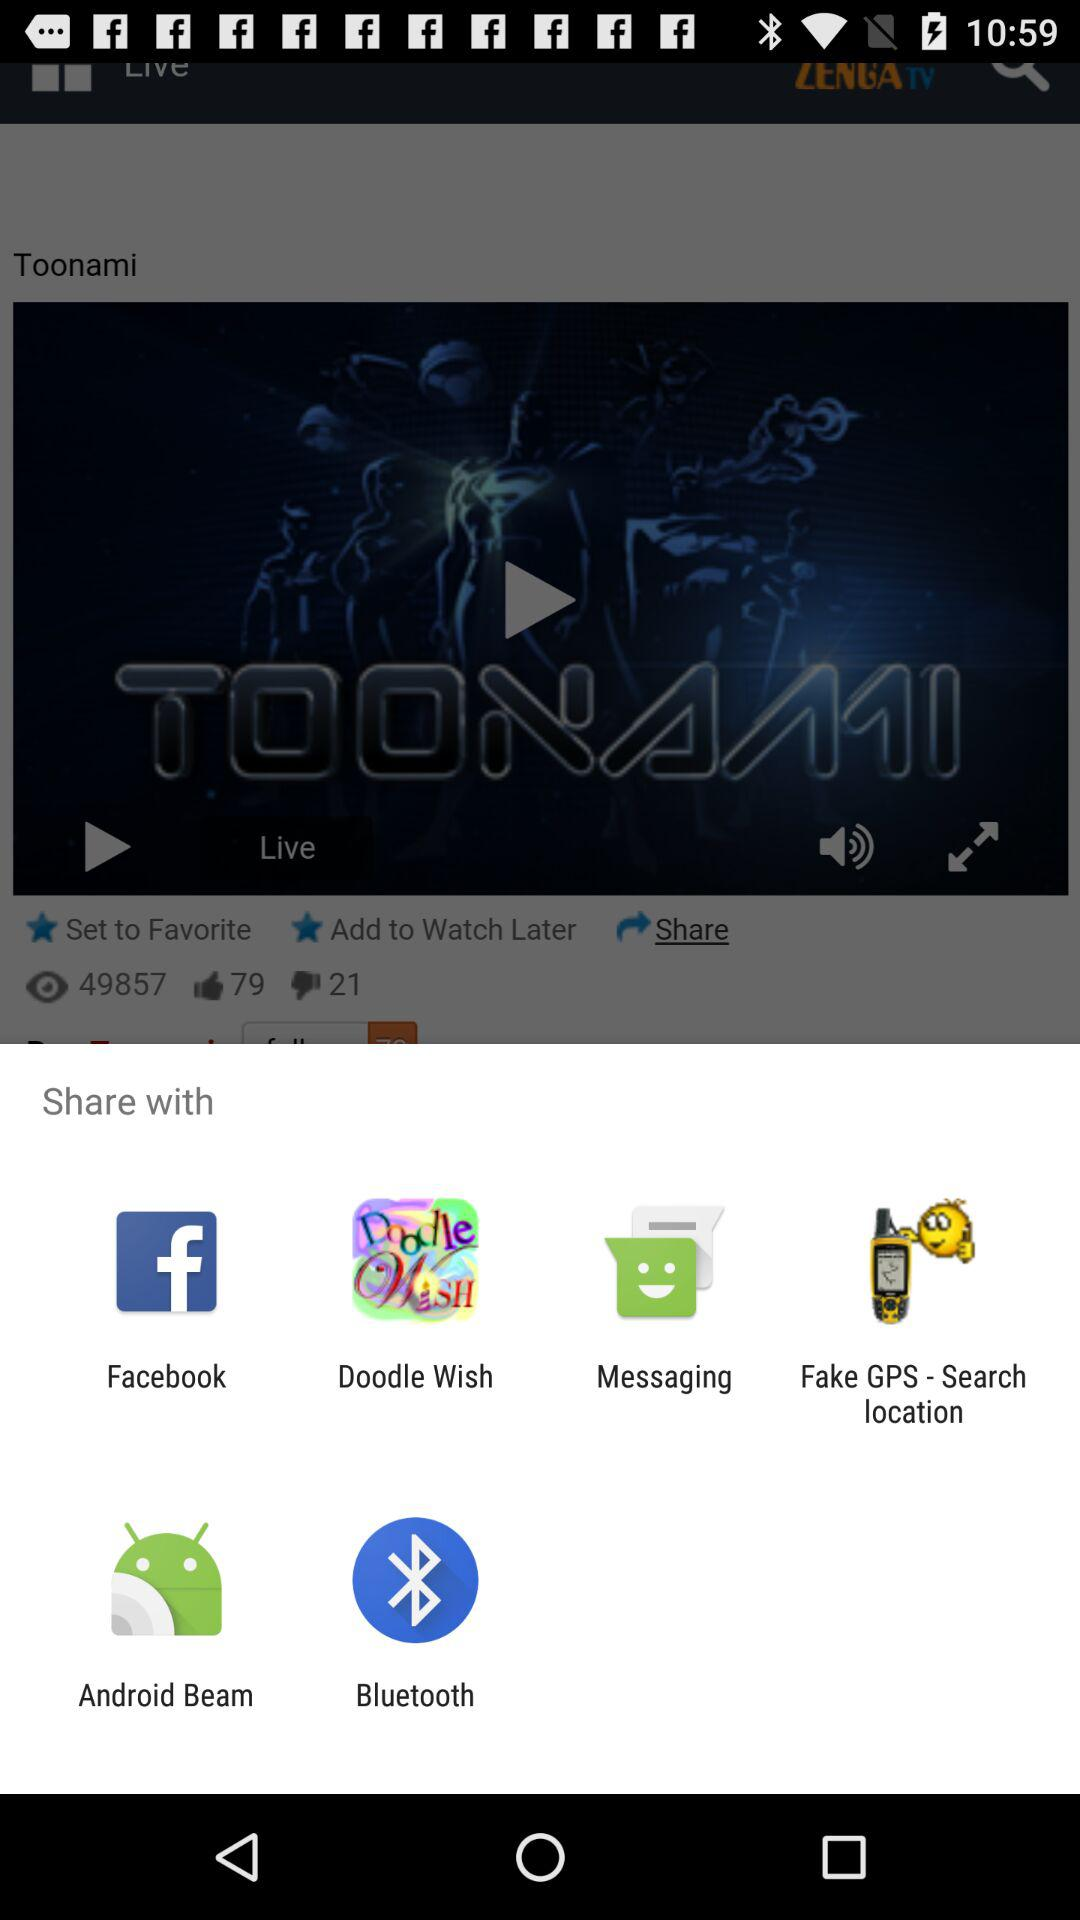Through which app can it be shared? It can be shared through "Facebook", "Doodle Wish", "Messaging", "Fake GPS - Search location", "Android Beam" and "Bluetooth". 